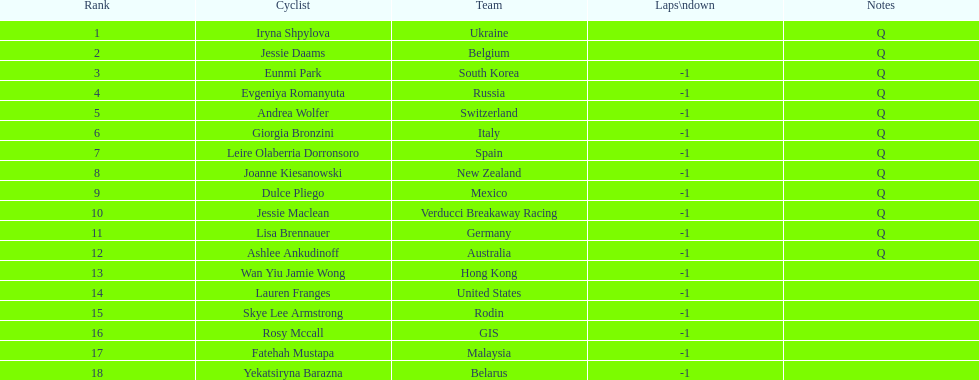Who is the final cyclist mentioned? Yekatsiryna Barazna. Parse the full table. {'header': ['Rank', 'Cyclist', 'Team', 'Laps\\ndown', 'Notes'], 'rows': [['1', 'Iryna Shpylova', 'Ukraine', '', 'Q'], ['2', 'Jessie Daams', 'Belgium', '', 'Q'], ['3', 'Eunmi Park', 'South Korea', '-1', 'Q'], ['4', 'Evgeniya Romanyuta', 'Russia', '-1', 'Q'], ['5', 'Andrea Wolfer', 'Switzerland', '-1', 'Q'], ['6', 'Giorgia Bronzini', 'Italy', '-1', 'Q'], ['7', 'Leire Olaberria Dorronsoro', 'Spain', '-1', 'Q'], ['8', 'Joanne Kiesanowski', 'New Zealand', '-1', 'Q'], ['9', 'Dulce Pliego', 'Mexico', '-1', 'Q'], ['10', 'Jessie Maclean', 'Verducci Breakaway Racing', '-1', 'Q'], ['11', 'Lisa Brennauer', 'Germany', '-1', 'Q'], ['12', 'Ashlee Ankudinoff', 'Australia', '-1', 'Q'], ['13', 'Wan Yiu Jamie Wong', 'Hong Kong', '-1', ''], ['14', 'Lauren Franges', 'United States', '-1', ''], ['15', 'Skye Lee Armstrong', 'Rodin', '-1', ''], ['16', 'Rosy Mccall', 'GIS', '-1', ''], ['17', 'Fatehah Mustapa', 'Malaysia', '-1', ''], ['18', 'Yekatsiryna Barazna', 'Belarus', '-1', '']]} 